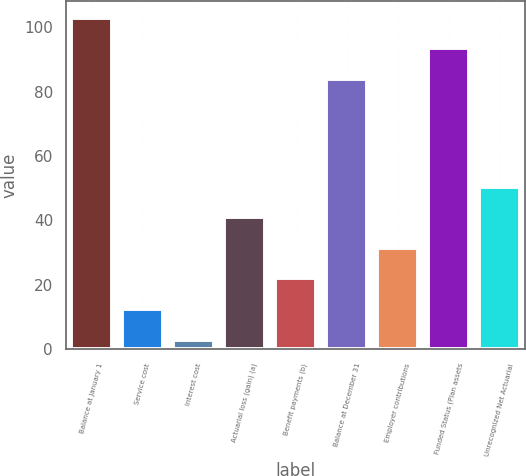Convert chart to OTSL. <chart><loc_0><loc_0><loc_500><loc_500><bar_chart><fcel>Balance at January 1<fcel>Service cost<fcel>Interest cost<fcel>Actuarial loss (gain) (a)<fcel>Benefit payments (b)<fcel>Balance at December 31<fcel>Employer contributions<fcel>Funded Status (Plan assets<fcel>Unrecognized Net Actuarial<nl><fcel>103<fcel>12.5<fcel>3<fcel>41<fcel>22<fcel>84<fcel>31.5<fcel>93.5<fcel>50.5<nl></chart> 